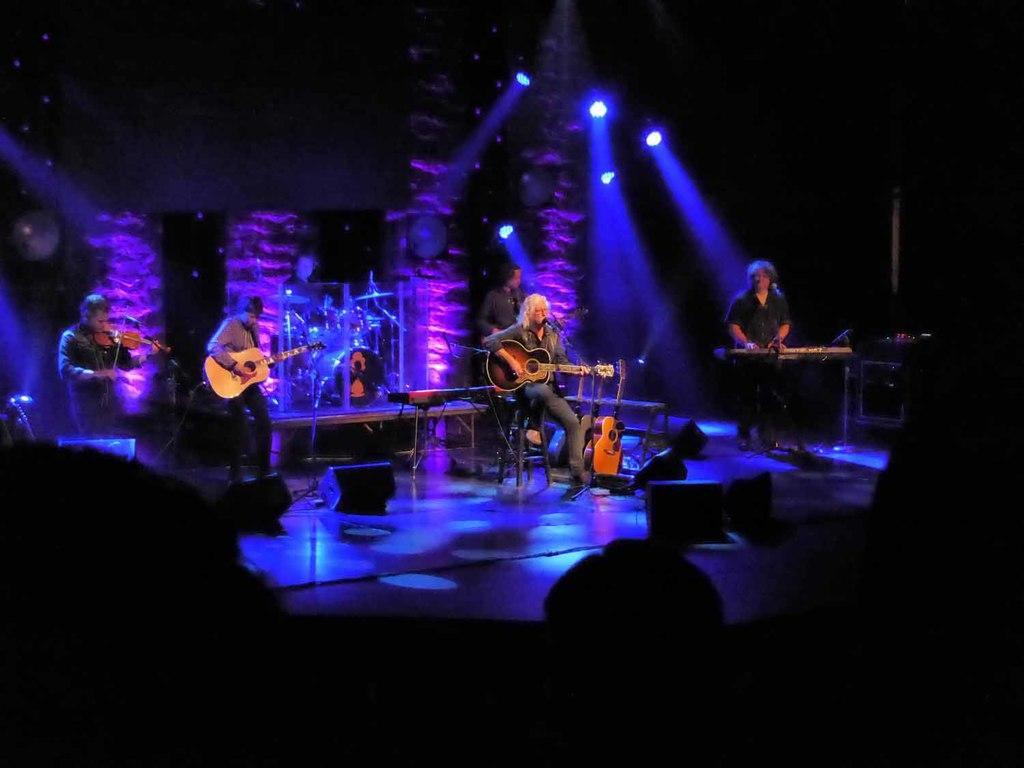Please provide a concise description of this image. In this image, there are group of people sitting on the chair and singing and playing a guitar in mike. In the bottom of the image, there are group of people sitting, an audience. On the top there are focus lights. The background is dark in color. It looks as if the image is taken in a concert area. 